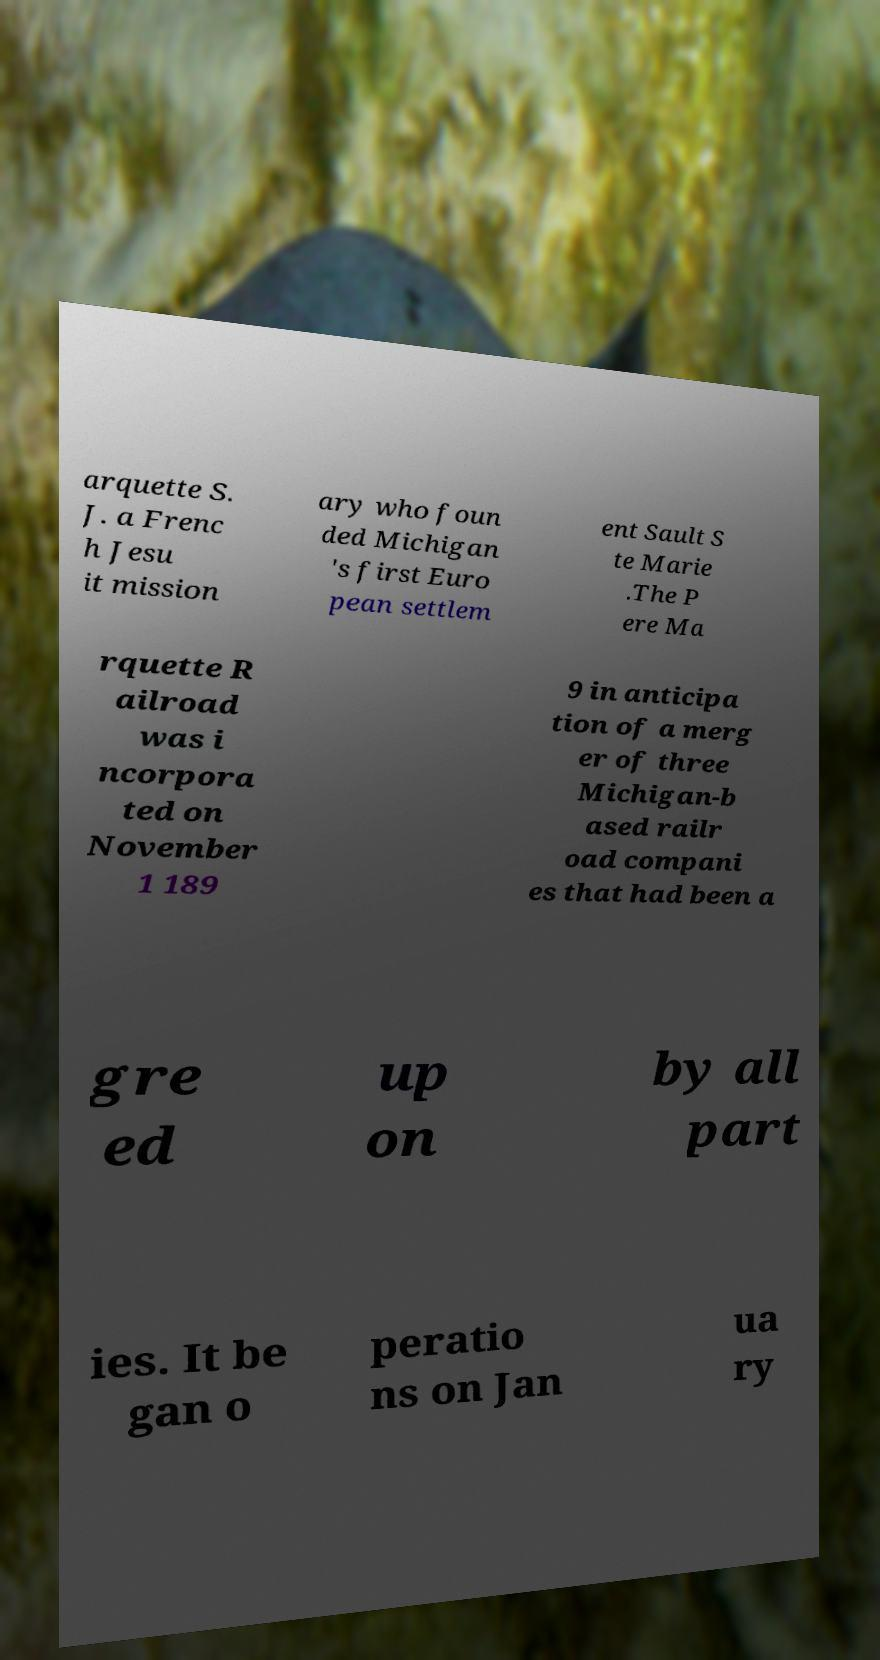For documentation purposes, I need the text within this image transcribed. Could you provide that? arquette S. J. a Frenc h Jesu it mission ary who foun ded Michigan 's first Euro pean settlem ent Sault S te Marie .The P ere Ma rquette R ailroad was i ncorpora ted on November 1 189 9 in anticipa tion of a merg er of three Michigan-b ased railr oad compani es that had been a gre ed up on by all part ies. It be gan o peratio ns on Jan ua ry 